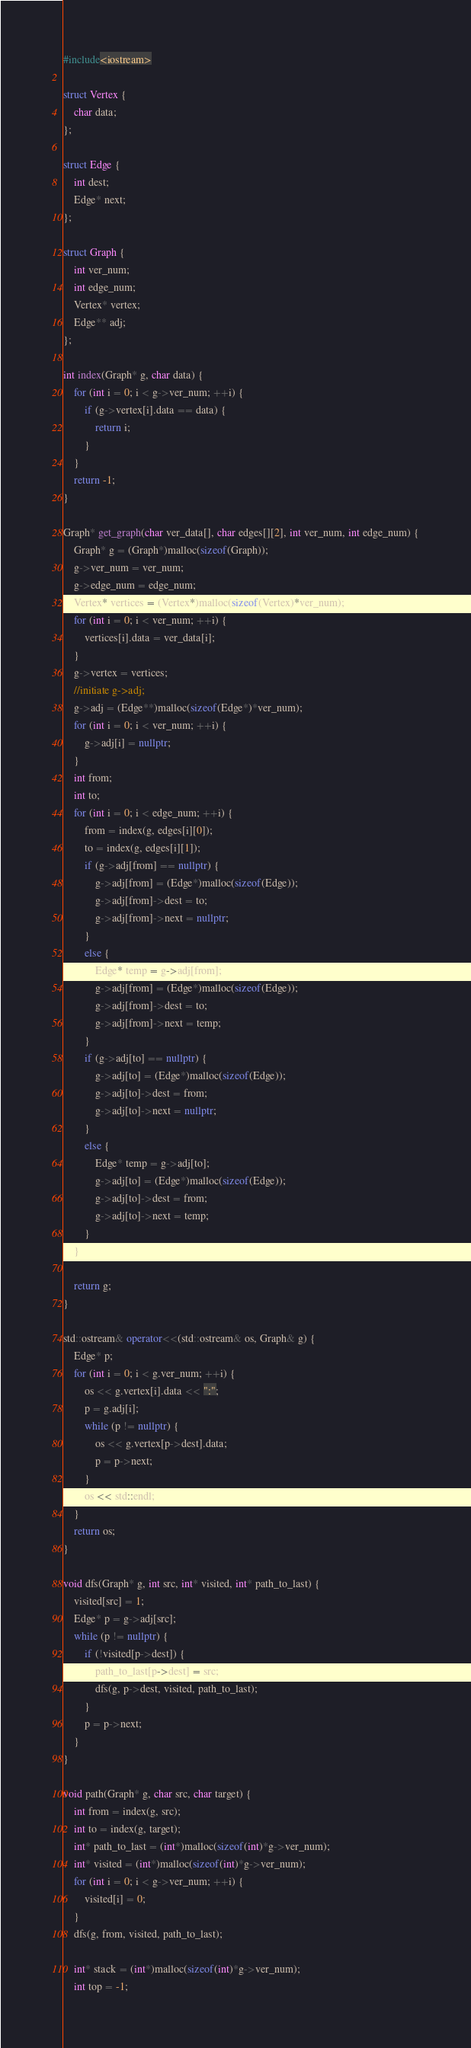Convert code to text. <code><loc_0><loc_0><loc_500><loc_500><_C++_>#include<iostream>

struct Vertex {
	char data;
};

struct Edge {
	int dest;
	Edge* next;
};

struct Graph {
	int ver_num;
	int edge_num;
	Vertex* vertex;
	Edge** adj;
};

int index(Graph* g, char data) {
	for (int i = 0; i < g->ver_num; ++i) {
		if (g->vertex[i].data == data) {
			return i;
		}
	}
	return -1;
}

Graph* get_graph(char ver_data[], char edges[][2], int ver_num, int edge_num) {
	Graph* g = (Graph*)malloc(sizeof(Graph));
	g->ver_num = ver_num;
	g->edge_num = edge_num;
	Vertex* vertices = (Vertex*)malloc(sizeof(Vertex)*ver_num);
	for (int i = 0; i < ver_num; ++i) {
		vertices[i].data = ver_data[i];
	}
	g->vertex = vertices;
	//initiate g->adj;
	g->adj = (Edge**)malloc(sizeof(Edge*)*ver_num);
	for (int i = 0; i < ver_num; ++i) {
		g->adj[i] = nullptr;
	}
	int from;
	int to;
	for (int i = 0; i < edge_num; ++i) {
		from = index(g, edges[i][0]);
		to = index(g, edges[i][1]);
		if (g->adj[from] == nullptr) {
			g->adj[from] = (Edge*)malloc(sizeof(Edge));
			g->adj[from]->dest = to;
			g->adj[from]->next = nullptr;
		}
		else {
			Edge* temp = g->adj[from];
			g->adj[from] = (Edge*)malloc(sizeof(Edge));
			g->adj[from]->dest = to;
			g->adj[from]->next = temp;
		}
		if (g->adj[to] == nullptr) {
			g->adj[to] = (Edge*)malloc(sizeof(Edge));
			g->adj[to]->dest = from;
			g->adj[to]->next = nullptr;
		}
		else {
			Edge* temp = g->adj[to];
			g->adj[to] = (Edge*)malloc(sizeof(Edge));
			g->adj[to]->dest = from;
			g->adj[to]->next = temp;
		}
	}

	return g;
}

std::ostream& operator<<(std::ostream& os, Graph& g) {
	Edge* p;
	for (int i = 0; i < g.ver_num; ++i) {
		os << g.vertex[i].data << ":";
		p = g.adj[i];
		while (p != nullptr) {
			os << g.vertex[p->dest].data;
			p = p->next;
		}
		os << std::endl;
	}
	return os;
}

void dfs(Graph* g, int src, int* visited, int* path_to_last) {
	visited[src] = 1;
	Edge* p = g->adj[src];
	while (p != nullptr) {
		if (!visited[p->dest]) {
			path_to_last[p->dest] = src;
			dfs(g, p->dest, visited, path_to_last);
		}
		p = p->next;
	}
}

void path(Graph* g, char src, char target) {
	int from = index(g, src);
	int to = index(g, target);
	int* path_to_last = (int*)malloc(sizeof(int)*g->ver_num);
	int* visited = (int*)malloc(sizeof(int)*g->ver_num);
	for (int i = 0; i < g->ver_num; ++i) {
		visited[i] = 0;
	}
	dfs(g, from, visited, path_to_last);

	int* stack = (int*)malloc(sizeof(int)*g->ver_num);
	int top = -1;</code> 